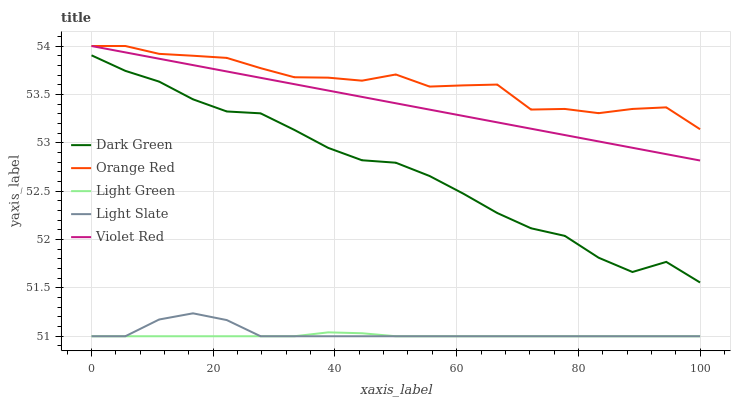Does Light Green have the minimum area under the curve?
Answer yes or no. Yes. Does Orange Red have the maximum area under the curve?
Answer yes or no. Yes. Does Violet Red have the minimum area under the curve?
Answer yes or no. No. Does Violet Red have the maximum area under the curve?
Answer yes or no. No. Is Violet Red the smoothest?
Answer yes or no. Yes. Is Orange Red the roughest?
Answer yes or no. Yes. Is Orange Red the smoothest?
Answer yes or no. No. Is Violet Red the roughest?
Answer yes or no. No. Does Light Slate have the lowest value?
Answer yes or no. Yes. Does Violet Red have the lowest value?
Answer yes or no. No. Does Orange Red have the highest value?
Answer yes or no. Yes. Does Light Green have the highest value?
Answer yes or no. No. Is Light Slate less than Violet Red?
Answer yes or no. Yes. Is Dark Green greater than Light Green?
Answer yes or no. Yes. Does Light Slate intersect Light Green?
Answer yes or no. Yes. Is Light Slate less than Light Green?
Answer yes or no. No. Is Light Slate greater than Light Green?
Answer yes or no. No. Does Light Slate intersect Violet Red?
Answer yes or no. No. 